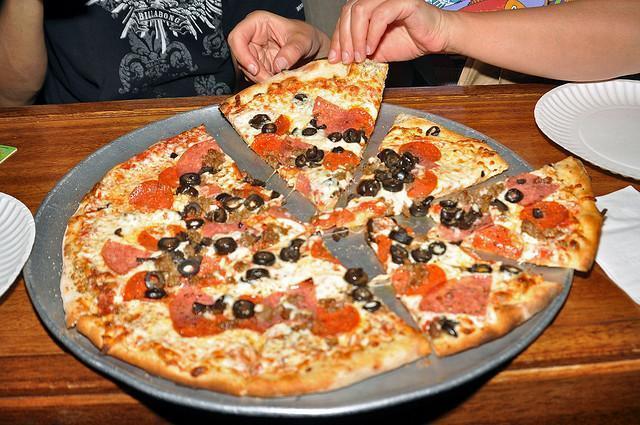How many slices are cut from the pizza?
Give a very brief answer. 4. How many people can be seen?
Give a very brief answer. 2. 